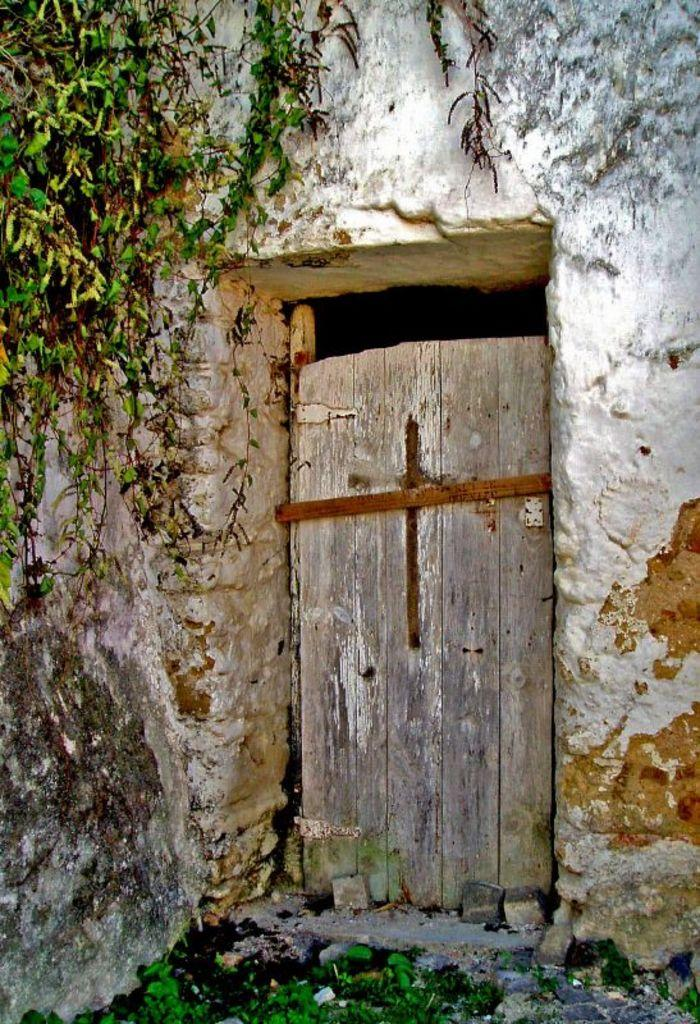What is one of the main features of the image? There is a door in the image. Where is the door located? The door is part of a wall. What type of vegetation can be seen at the bottom of the image? There are plants at the bottom of the image. Can you describe the plant in the top left corner of the image? There is a creeper plant in the top left corner of the image. What type of stone can be seen in the image? There is no stone present in the image. Can you touch the creeper plant in the image? It is not possible to touch the creeper plant in the image, as it is a two-dimensional representation. 